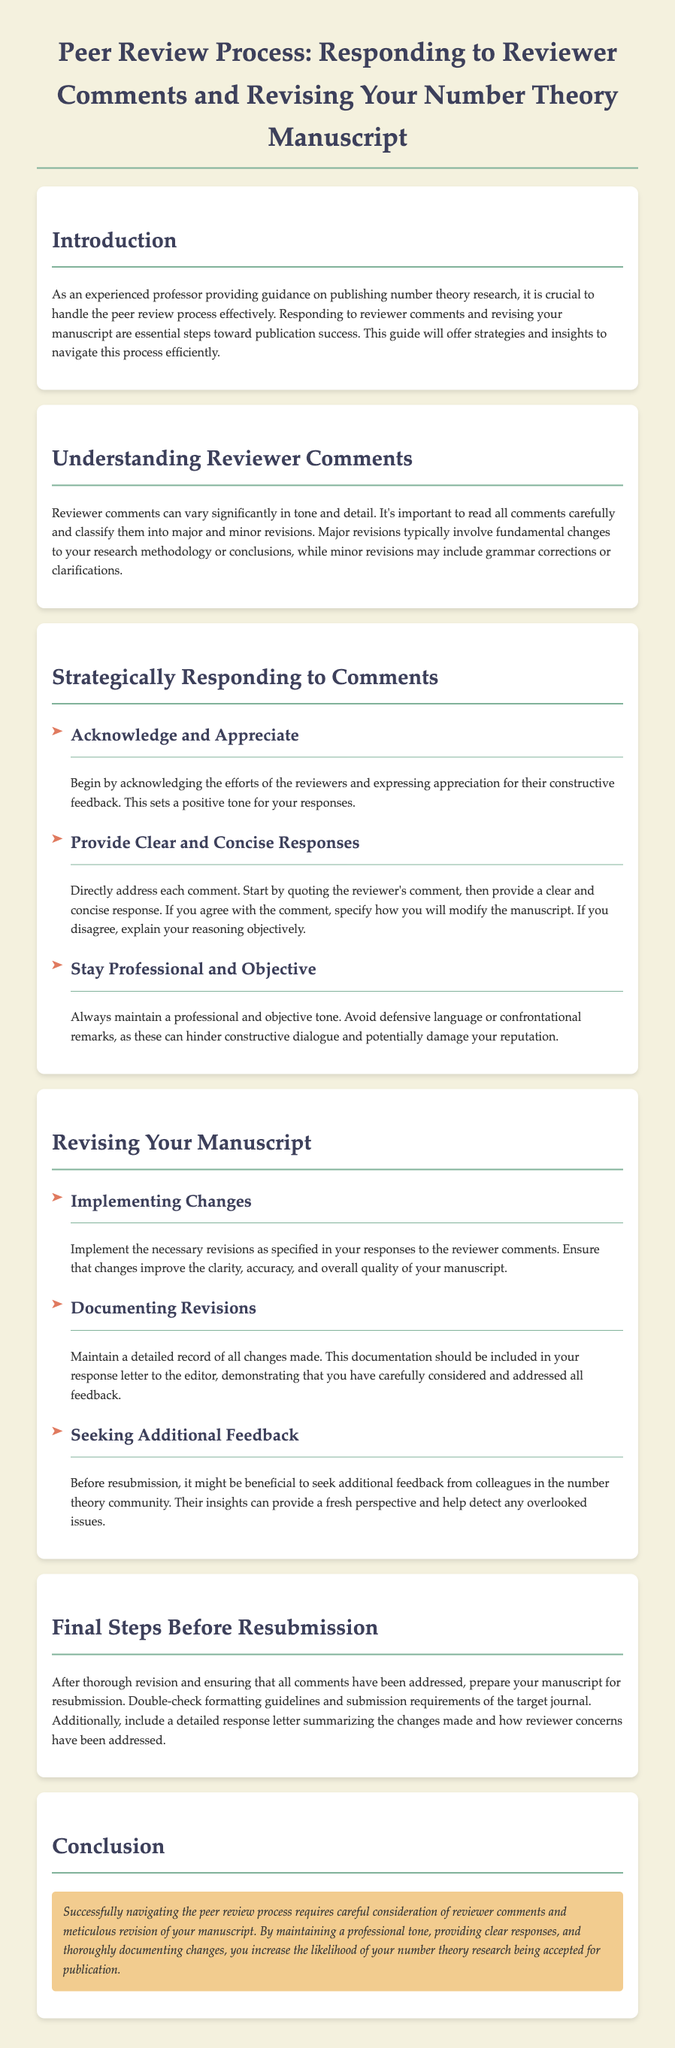What is the title of the document? The title appears in the header section of the document, which is "Peer Review Process: Responding to Reviewer Comments and Revising Your Number Theory Manuscript."
Answer: Peer Review Process: Responding to Reviewer Comments and Revising Your Number Theory Manuscript What is the main focus of the guide? The guide emphasizes effective handling of the peer review process, particularly in responding to comments and revising manuscripts.
Answer: Handling the peer review process What are the two types of revisions mentioned? The document classifies revisions into major and minor categories based on impact and detail.
Answer: Major and minor revisions What is the first step in strategically responding to reviewer comments? According to the document, the initial step is to acknowledge the efforts of the reviewers.
Answer: Acknowledge and Appreciate How should you document revisions? The guide states that maintaining a detailed record of all changes made is essential for the response letter to the editor.
Answer: Detailed record of all changes What should you do before resubmission? The document highlights the importance of double-checking formatting guidelines and submission requirements.
Answer: Double-check formatting guidelines How can you seek additional feedback? The guide suggests reaching out to colleagues in the number theory community for insights before resubmission.
Answer: Seeking feedback from colleagues What tone should be maintained when responding to comments? The document specifies that a professional and objective tone should be maintained throughout responses.
Answer: Professional and objective tone 